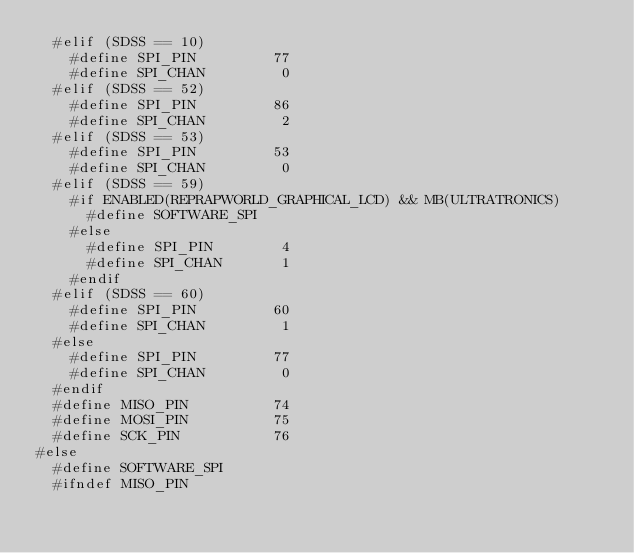<code> <loc_0><loc_0><loc_500><loc_500><_C_>  #elif (SDSS == 10)
    #define SPI_PIN         77
    #define SPI_CHAN         0
  #elif (SDSS == 52)
    #define SPI_PIN         86
    #define SPI_CHAN         2
  #elif (SDSS == 53)
    #define SPI_PIN         53
    #define SPI_CHAN         0
  #elif (SDSS == 59)
    #if ENABLED(REPRAPWORLD_GRAPHICAL_LCD) && MB(ULTRATRONICS)
      #define SOFTWARE_SPI
    #else
      #define SPI_PIN        4
      #define SPI_CHAN       1
    #endif
  #elif (SDSS == 60)
    #define SPI_PIN         60
    #define SPI_CHAN         1
  #else
    #define SPI_PIN         77
    #define SPI_CHAN         0
  #endif
  #define MISO_PIN          74
  #define MOSI_PIN          75
  #define SCK_PIN           76
#else
  #define SOFTWARE_SPI
  #ifndef MISO_PIN</code> 